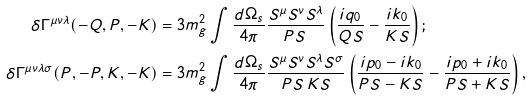<formula> <loc_0><loc_0><loc_500><loc_500>\delta \Gamma ^ { \mu \nu \lambda } ( - Q , P , - K ) & = 3 m _ { g } ^ { 2 } \int \frac { d \Omega _ { s } } { 4 \pi } \frac { S ^ { \mu } S ^ { \nu } S ^ { \lambda } } { P S \, } \left ( \frac { i q _ { 0 } } { Q S } - \frac { i k _ { 0 } } { K S } \right ) ; \\ \delta \Gamma ^ { \mu \nu \lambda \sigma } ( P , - P , K , - K ) & = 3 m _ { g } ^ { 2 } \int \frac { d \Omega _ { s } } { 4 \pi } \frac { S ^ { \mu } S ^ { \nu } S ^ { \lambda } S ^ { \sigma } } { P S \, K S } \left ( \frac { i p _ { 0 } - i k _ { 0 } } { P S - K S } - \frac { i p _ { 0 } + i k _ { 0 } } { P S + K S } \right ) ,</formula> 